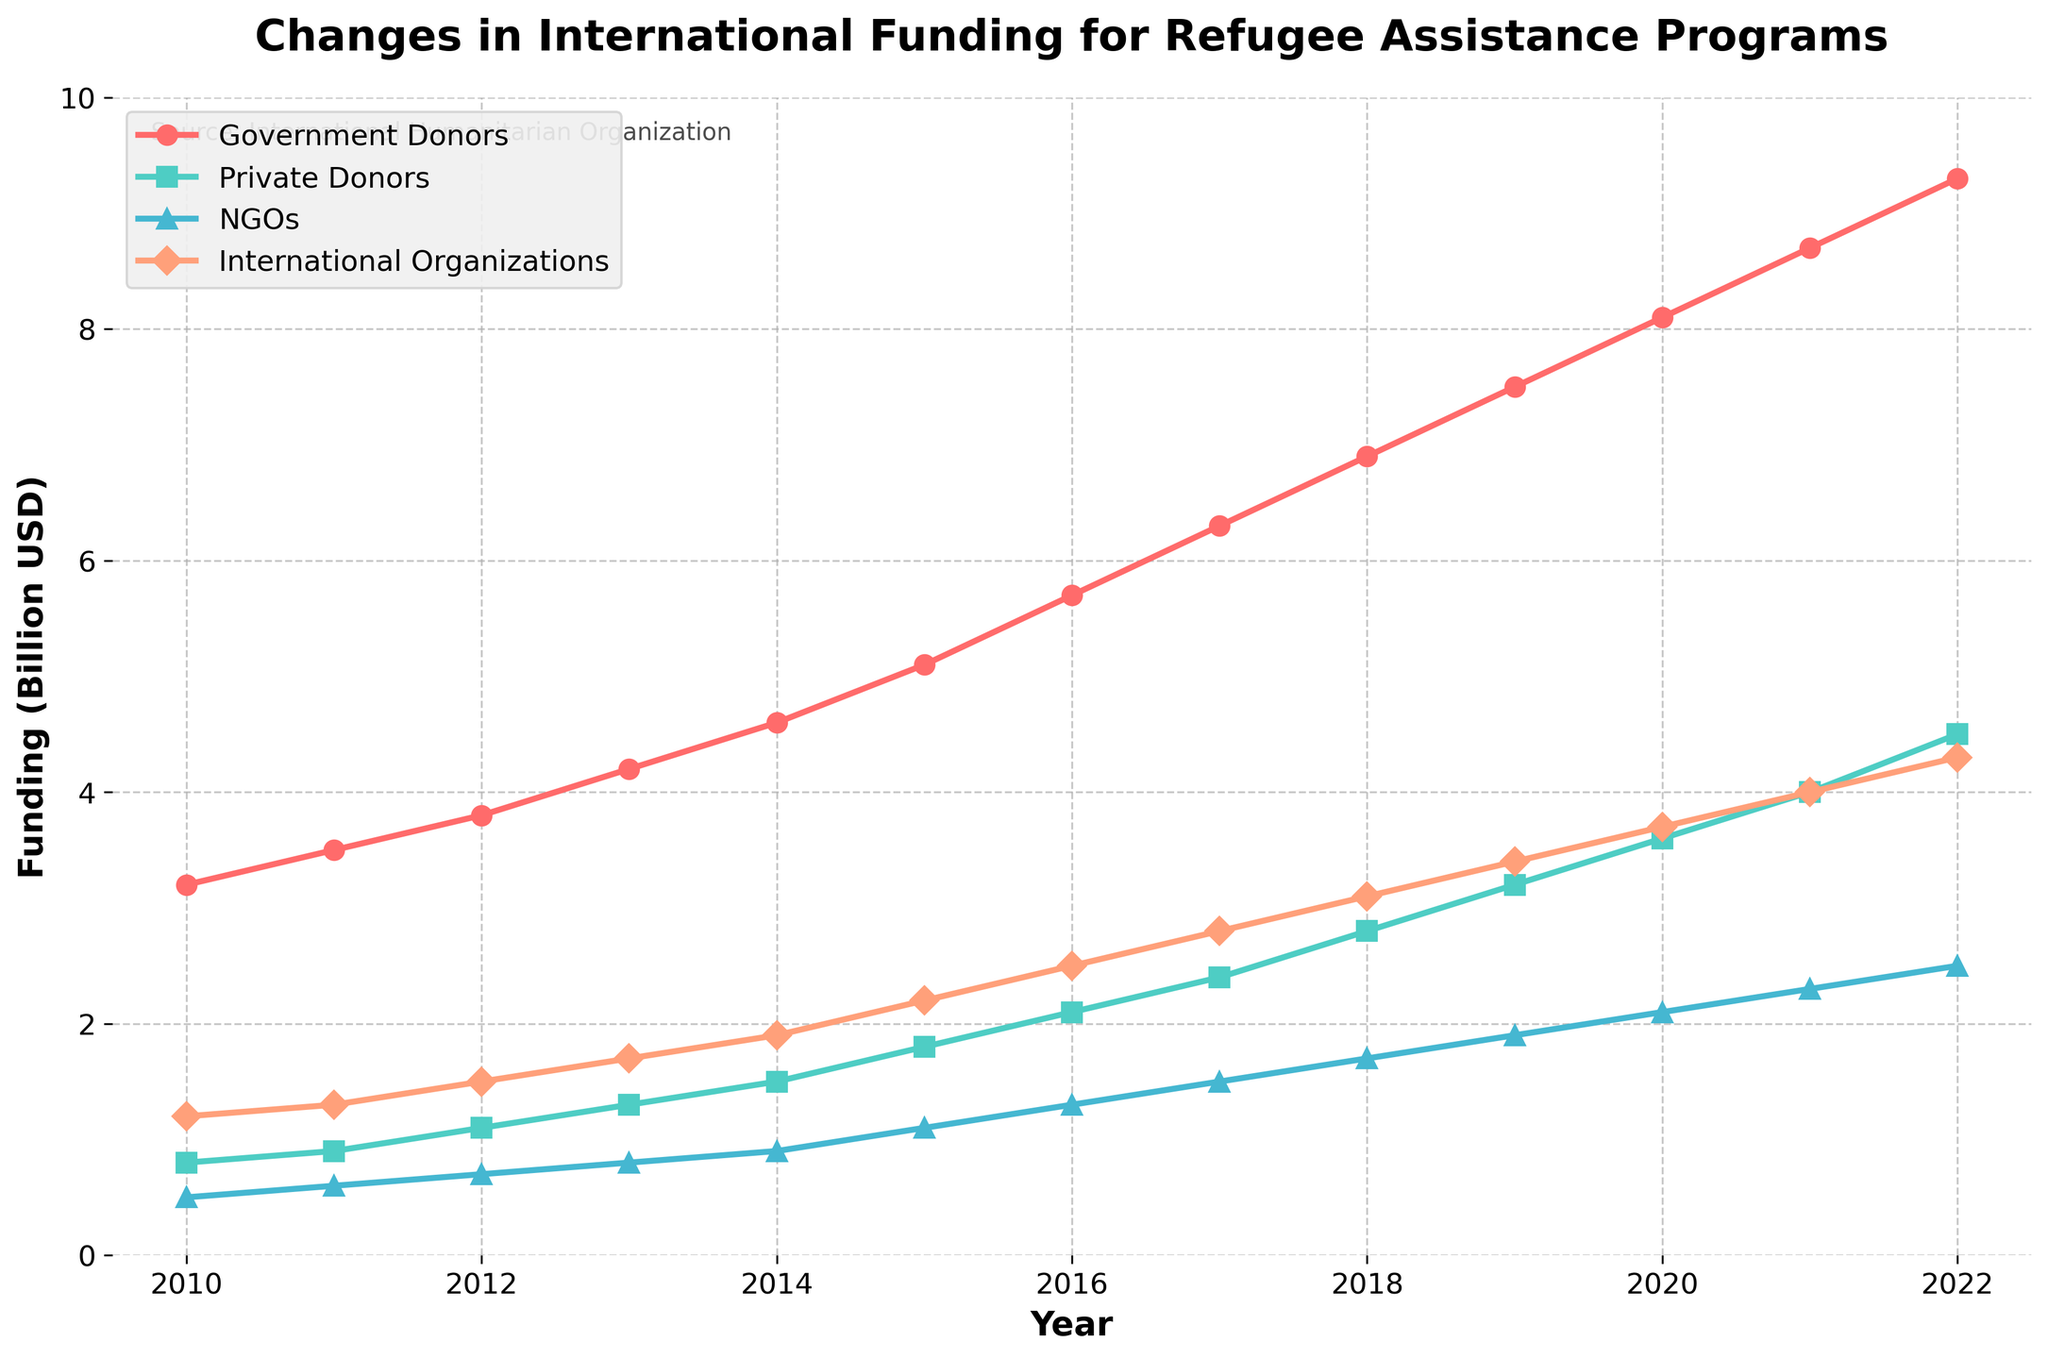What was the total funding for refugee assistance programs in 2022? The funding in 2022 from different donors were: Government Donors (9.3), Private Donors (4.5), NGOs (2.5), and International Organizations (4.3). Summing them up: 9.3 + 4.5 + 2.5 + 4.3 = 20.6 billion USD.
Answer: 20.6 billion USD Which year had the highest amount of funding from Government Donors? Observing the visual trend, funding from Government Donors increases over time and the highest amount is in 2022.
Answer: 2022 By how much did the funding from NGOs increase from 2010 to 2022? The funding from NGOs in 2010 was 0.5 billion USD and in 2022 it was 2.5 billion USD. The increase is calculated as 2.5 - 0.5 = 2.0 billion USD.
Answer: 2.0 billion USD In which year did Private Donors surpass 3 billion USD in funding? Observing the visual trend, Private Donors surpassed 3 billion USD in the year 2019.
Answer: 2019 Which donor type had the least increase in funding from 2010 to 2022? Calculate the increase for each donor from 2010 to 2022: Government Donors (9.3 - 3.2 = 6.1), Private Donors (4.5 - 0.8 = 3.7), NGOs (2.5 - 0.5 = 2.0), International Organizations (4.3 - 1.2 = 3.1). The least increase was from NGOs.
Answer: NGOs What is the average funding provided by International Organizations from 2010 to 2022? Summing the funding from International Organizations from 2010 to 2022: 1.2 + 1.3 + 1.5 + 1.7 + 1.9 + 2.2 + 2.5 + 2.8 + 3.1 + 3.4 + 3.7 + 4.0 + 4.3 = 33.6 billion USD. There are 13 years, so the average is 33.6 / 13 ≈ 2.585 billion USD.
Answer: 2.585 billion USD Which funding source saw the largest relative increase over the period 2010 to 2022? Calculate the relative increases: Government Donors ((9.3/3.2) - 1) * 100 ≈ 190.63%, Private Donors ((4.5/0.8) - 1) * 100 ≈ 462.5%, NGOs ((2.5/0.5) - 1) * 100 = 400%, International Organizations ((4.3/1.2) - 1) * 100 ≈ 258.33%. The largest relative increase is from Private Donors.
Answer: Private Donors Which year shows the steepest rise in funding from Government Donors compared to the previous year? The steepest rise can be observed by finding the greatest difference year-over-year for Government Donors. The largest difference, 0.8 billion USD, is between 2019 (7.5) and 2020 (8.1).
Answer: 2020 Compare the funding from Private Donors and International Organizations in 2018. Which was higher and by how much? In 2018, Private Donors provided 2.8 billion USD and International Organizations provided 3.1 billion USD. The difference is 3.1 - 2.8 = 0.3 billion USD. Therefore, International Organizations provided more by 0.3 billion USD.
Answer: International Organizations by 0.3 billion USD 